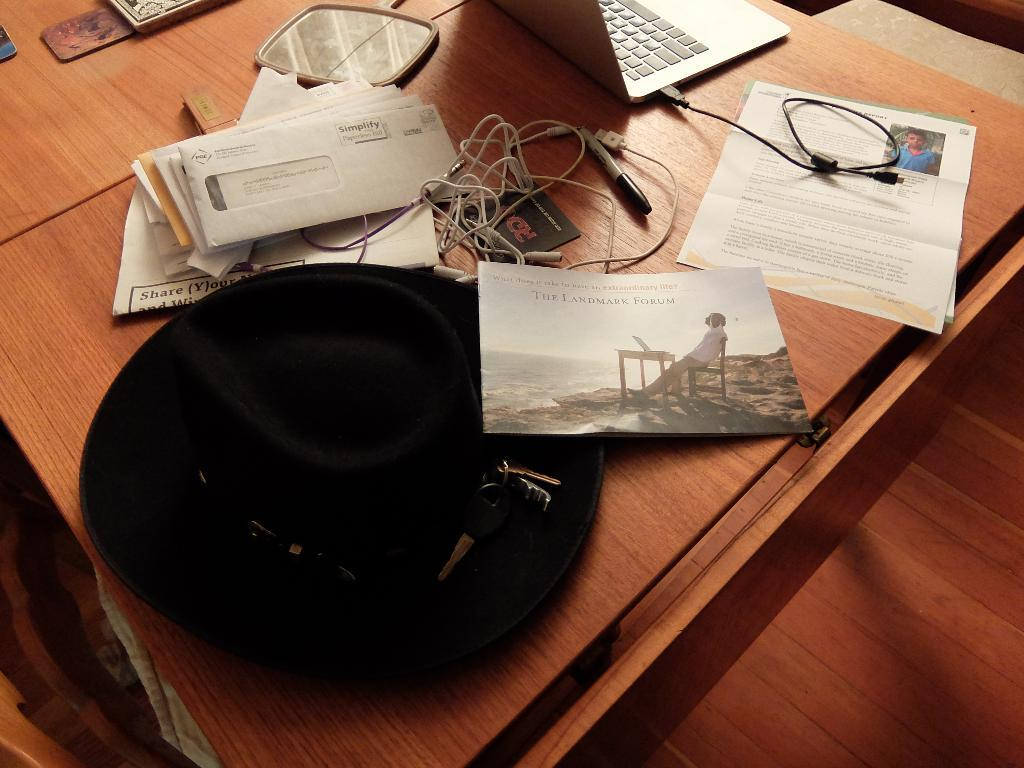What electronic device is visible in the image? There is a laptop in the image. What else can be seen connected to the laptop? There are cables in the image. What type of stationery item is present in the image? There is a group of papers in the image. What reflective object is in the image? There is a mirror in the image. What small object is present in the image? There is a key in the image. What type of clothing item is in the image? There is a hat in the image. On what surface are all these objects placed? All of these objects are placed on a table. What type of waves can be seen crashing on the shore in the image? There are no waves or shoreline present in the image; it features a laptop, cables, papers, a mirror, a key, and a hat on a table. 